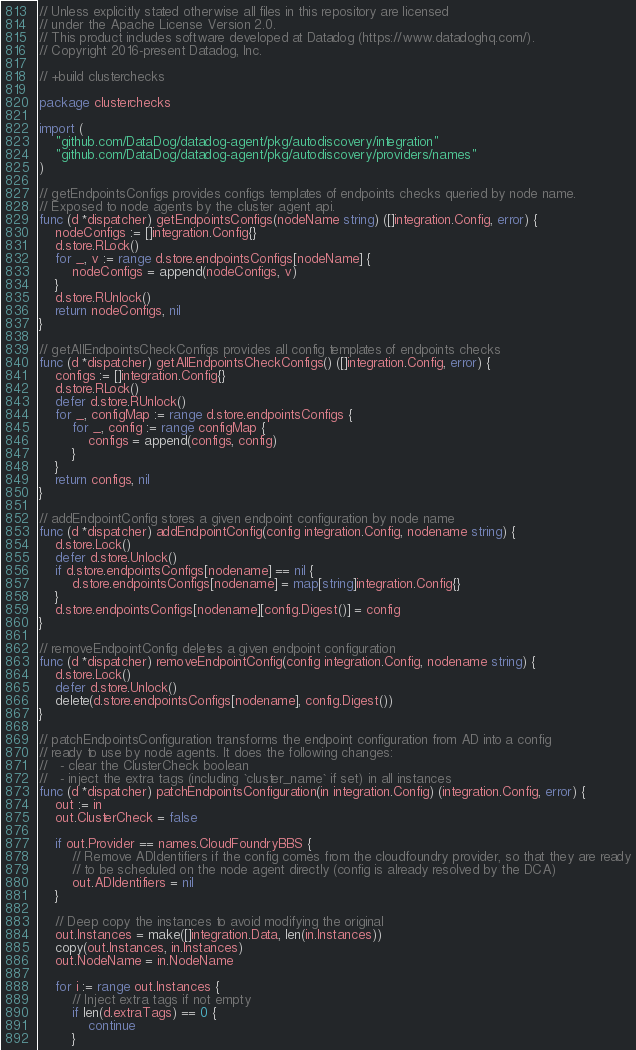<code> <loc_0><loc_0><loc_500><loc_500><_Go_>// Unless explicitly stated otherwise all files in this repository are licensed
// under the Apache License Version 2.0.
// This product includes software developed at Datadog (https://www.datadoghq.com/).
// Copyright 2016-present Datadog, Inc.

// +build clusterchecks

package clusterchecks

import (
	"github.com/DataDog/datadog-agent/pkg/autodiscovery/integration"
	"github.com/DataDog/datadog-agent/pkg/autodiscovery/providers/names"
)

// getEndpointsConfigs provides configs templates of endpoints checks queried by node name.
// Exposed to node agents by the cluster agent api.
func (d *dispatcher) getEndpointsConfigs(nodeName string) ([]integration.Config, error) {
	nodeConfigs := []integration.Config{}
	d.store.RLock()
	for _, v := range d.store.endpointsConfigs[nodeName] {
		nodeConfigs = append(nodeConfigs, v)
	}
	d.store.RUnlock()
	return nodeConfigs, nil
}

// getAllEndpointsCheckConfigs provides all config templates of endpoints checks
func (d *dispatcher) getAllEndpointsCheckConfigs() ([]integration.Config, error) {
	configs := []integration.Config{}
	d.store.RLock()
	defer d.store.RUnlock()
	for _, configMap := range d.store.endpointsConfigs {
		for _, config := range configMap {
			configs = append(configs, config)
		}
	}
	return configs, nil
}

// addEndpointConfig stores a given endpoint configuration by node name
func (d *dispatcher) addEndpointConfig(config integration.Config, nodename string) {
	d.store.Lock()
	defer d.store.Unlock()
	if d.store.endpointsConfigs[nodename] == nil {
		d.store.endpointsConfigs[nodename] = map[string]integration.Config{}
	}
	d.store.endpointsConfigs[nodename][config.Digest()] = config
}

// removeEndpointConfig deletes a given endpoint configuration
func (d *dispatcher) removeEndpointConfig(config integration.Config, nodename string) {
	d.store.Lock()
	defer d.store.Unlock()
	delete(d.store.endpointsConfigs[nodename], config.Digest())
}

// patchEndpointsConfiguration transforms the endpoint configuration from AD into a config
// ready to use by node agents. It does the following changes:
//   - clear the ClusterCheck boolean
//   - inject the extra tags (including `cluster_name` if set) in all instances
func (d *dispatcher) patchEndpointsConfiguration(in integration.Config) (integration.Config, error) {
	out := in
	out.ClusterCheck = false

	if out.Provider == names.CloudFoundryBBS {
		// Remove ADIdentifiers if the config comes from the cloudfoundry provider, so that they are ready
		// to be scheduled on the node agent directly (config is already resolved by the DCA)
		out.ADIdentifiers = nil
	}

	// Deep copy the instances to avoid modifying the original
	out.Instances = make([]integration.Data, len(in.Instances))
	copy(out.Instances, in.Instances)
	out.NodeName = in.NodeName

	for i := range out.Instances {
		// Inject extra tags if not empty
		if len(d.extraTags) == 0 {
			continue
		}</code> 